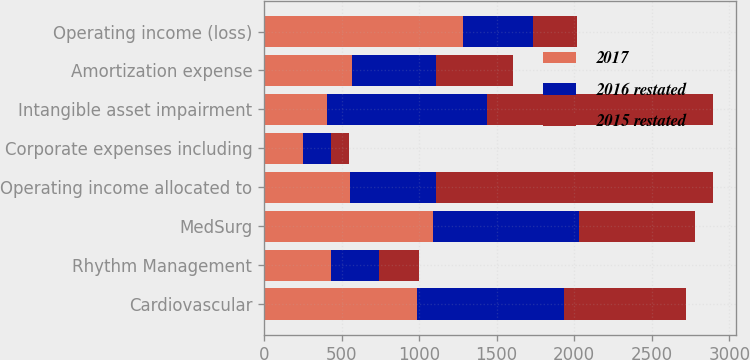<chart> <loc_0><loc_0><loc_500><loc_500><stacked_bar_chart><ecel><fcel>Cardiovascular<fcel>Rhythm Management<fcel>MedSurg<fcel>Operating income allocated to<fcel>Corporate expenses including<fcel>Intangible asset impairment<fcel>Amortization expense<fcel>Operating income (loss)<nl><fcel>2017<fcel>988<fcel>429<fcel>1092<fcel>555<fcel>252<fcel>407<fcel>565<fcel>1285<nl><fcel>2016 restated<fcel>946<fcel>314<fcel>941<fcel>555<fcel>179<fcel>1029<fcel>545<fcel>447<nl><fcel>2015 restated<fcel>788<fcel>255<fcel>745<fcel>1788<fcel>118<fcel>1458<fcel>495<fcel>283<nl></chart> 